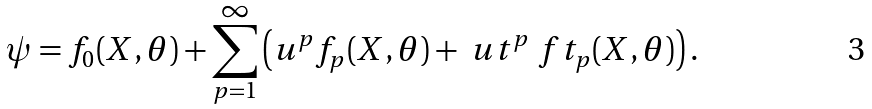Convert formula to latex. <formula><loc_0><loc_0><loc_500><loc_500>\psi = f _ { 0 } ( X , \theta ) + \sum _ { p = 1 } ^ { \infty } \left ( u ^ { p } f _ { p } ( X , \theta ) + \ u t ^ { p } \ f t _ { p } ( X , \theta ) \right ) .</formula> 